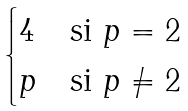<formula> <loc_0><loc_0><loc_500><loc_500>\begin{cases} 4 & \text {si } p = 2 \\ p & \text {si } p \neq 2 \end{cases}</formula> 